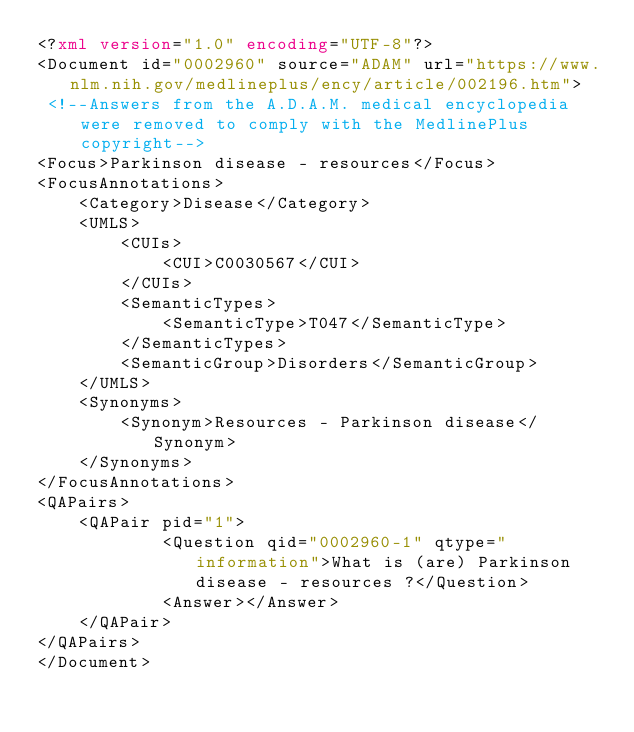Convert code to text. <code><loc_0><loc_0><loc_500><loc_500><_XML_><?xml version="1.0" encoding="UTF-8"?>
<Document id="0002960" source="ADAM" url="https://www.nlm.nih.gov/medlineplus/ency/article/002196.htm">
 <!--Answers from the A.D.A.M. medical encyclopedia were removed to comply with the MedlinePlus copyright-->
<Focus>Parkinson disease - resources</Focus>
<FocusAnnotations>
	<Category>Disease</Category>
	<UMLS>
		<CUIs>
			<CUI>C0030567</CUI>
		</CUIs>
		<SemanticTypes>
			<SemanticType>T047</SemanticType>
		</SemanticTypes>
		<SemanticGroup>Disorders</SemanticGroup>
	</UMLS>
	<Synonyms>
		<Synonym>Resources - Parkinson disease</Synonym>
	</Synonyms>
</FocusAnnotations>
<QAPairs>
	<QAPair pid="1">
			<Question qid="0002960-1" qtype="information">What is (are) Parkinson disease - resources ?</Question>
			<Answer></Answer>
	</QAPair>
</QAPairs>
</Document>
</code> 